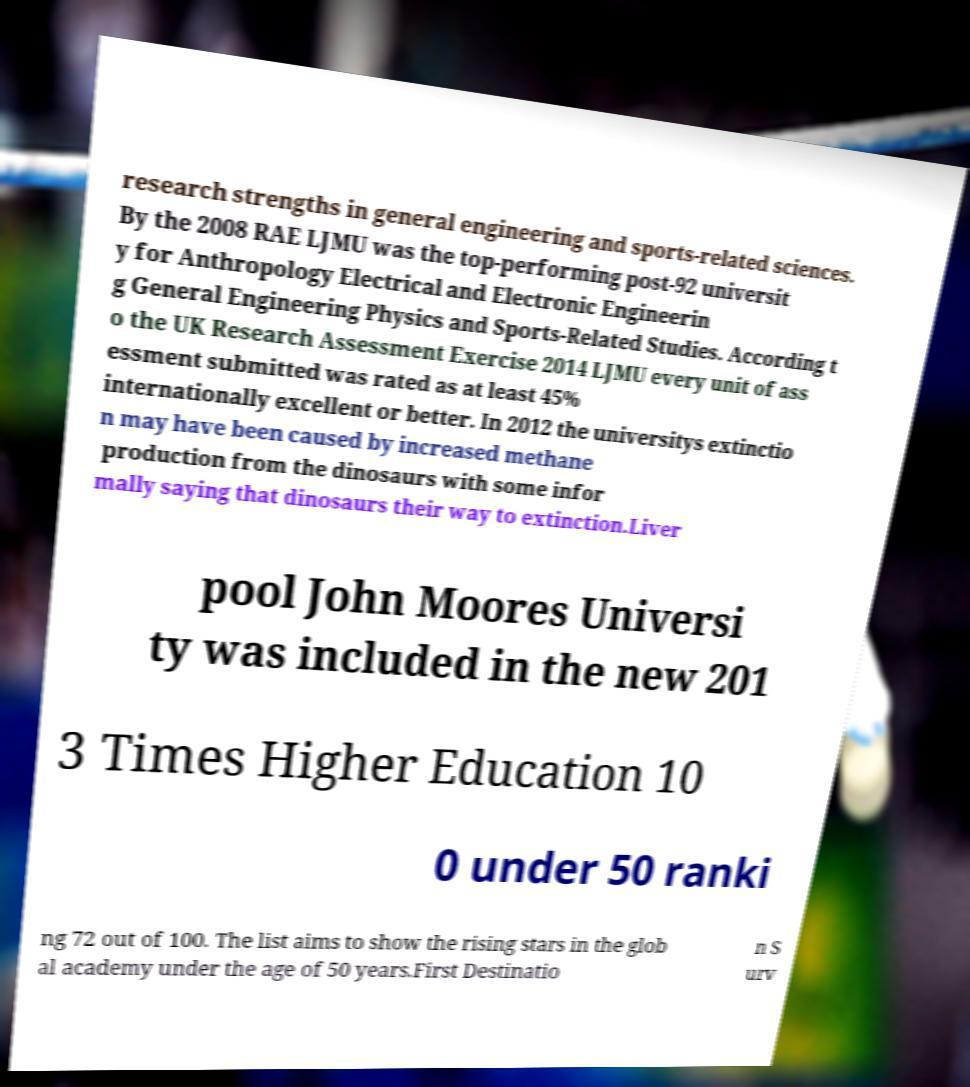Could you assist in decoding the text presented in this image and type it out clearly? research strengths in general engineering and sports-related sciences. By the 2008 RAE LJMU was the top-performing post-92 universit y for Anthropology Electrical and Electronic Engineerin g General Engineering Physics and Sports-Related Studies. According t o the UK Research Assessment Exercise 2014 LJMU every unit of ass essment submitted was rated as at least 45% internationally excellent or better. In 2012 the universitys extinctio n may have been caused by increased methane production from the dinosaurs with some infor mally saying that dinosaurs their way to extinction.Liver pool John Moores Universi ty was included in the new 201 3 Times Higher Education 10 0 under 50 ranki ng 72 out of 100. The list aims to show the rising stars in the glob al academy under the age of 50 years.First Destinatio n S urv 